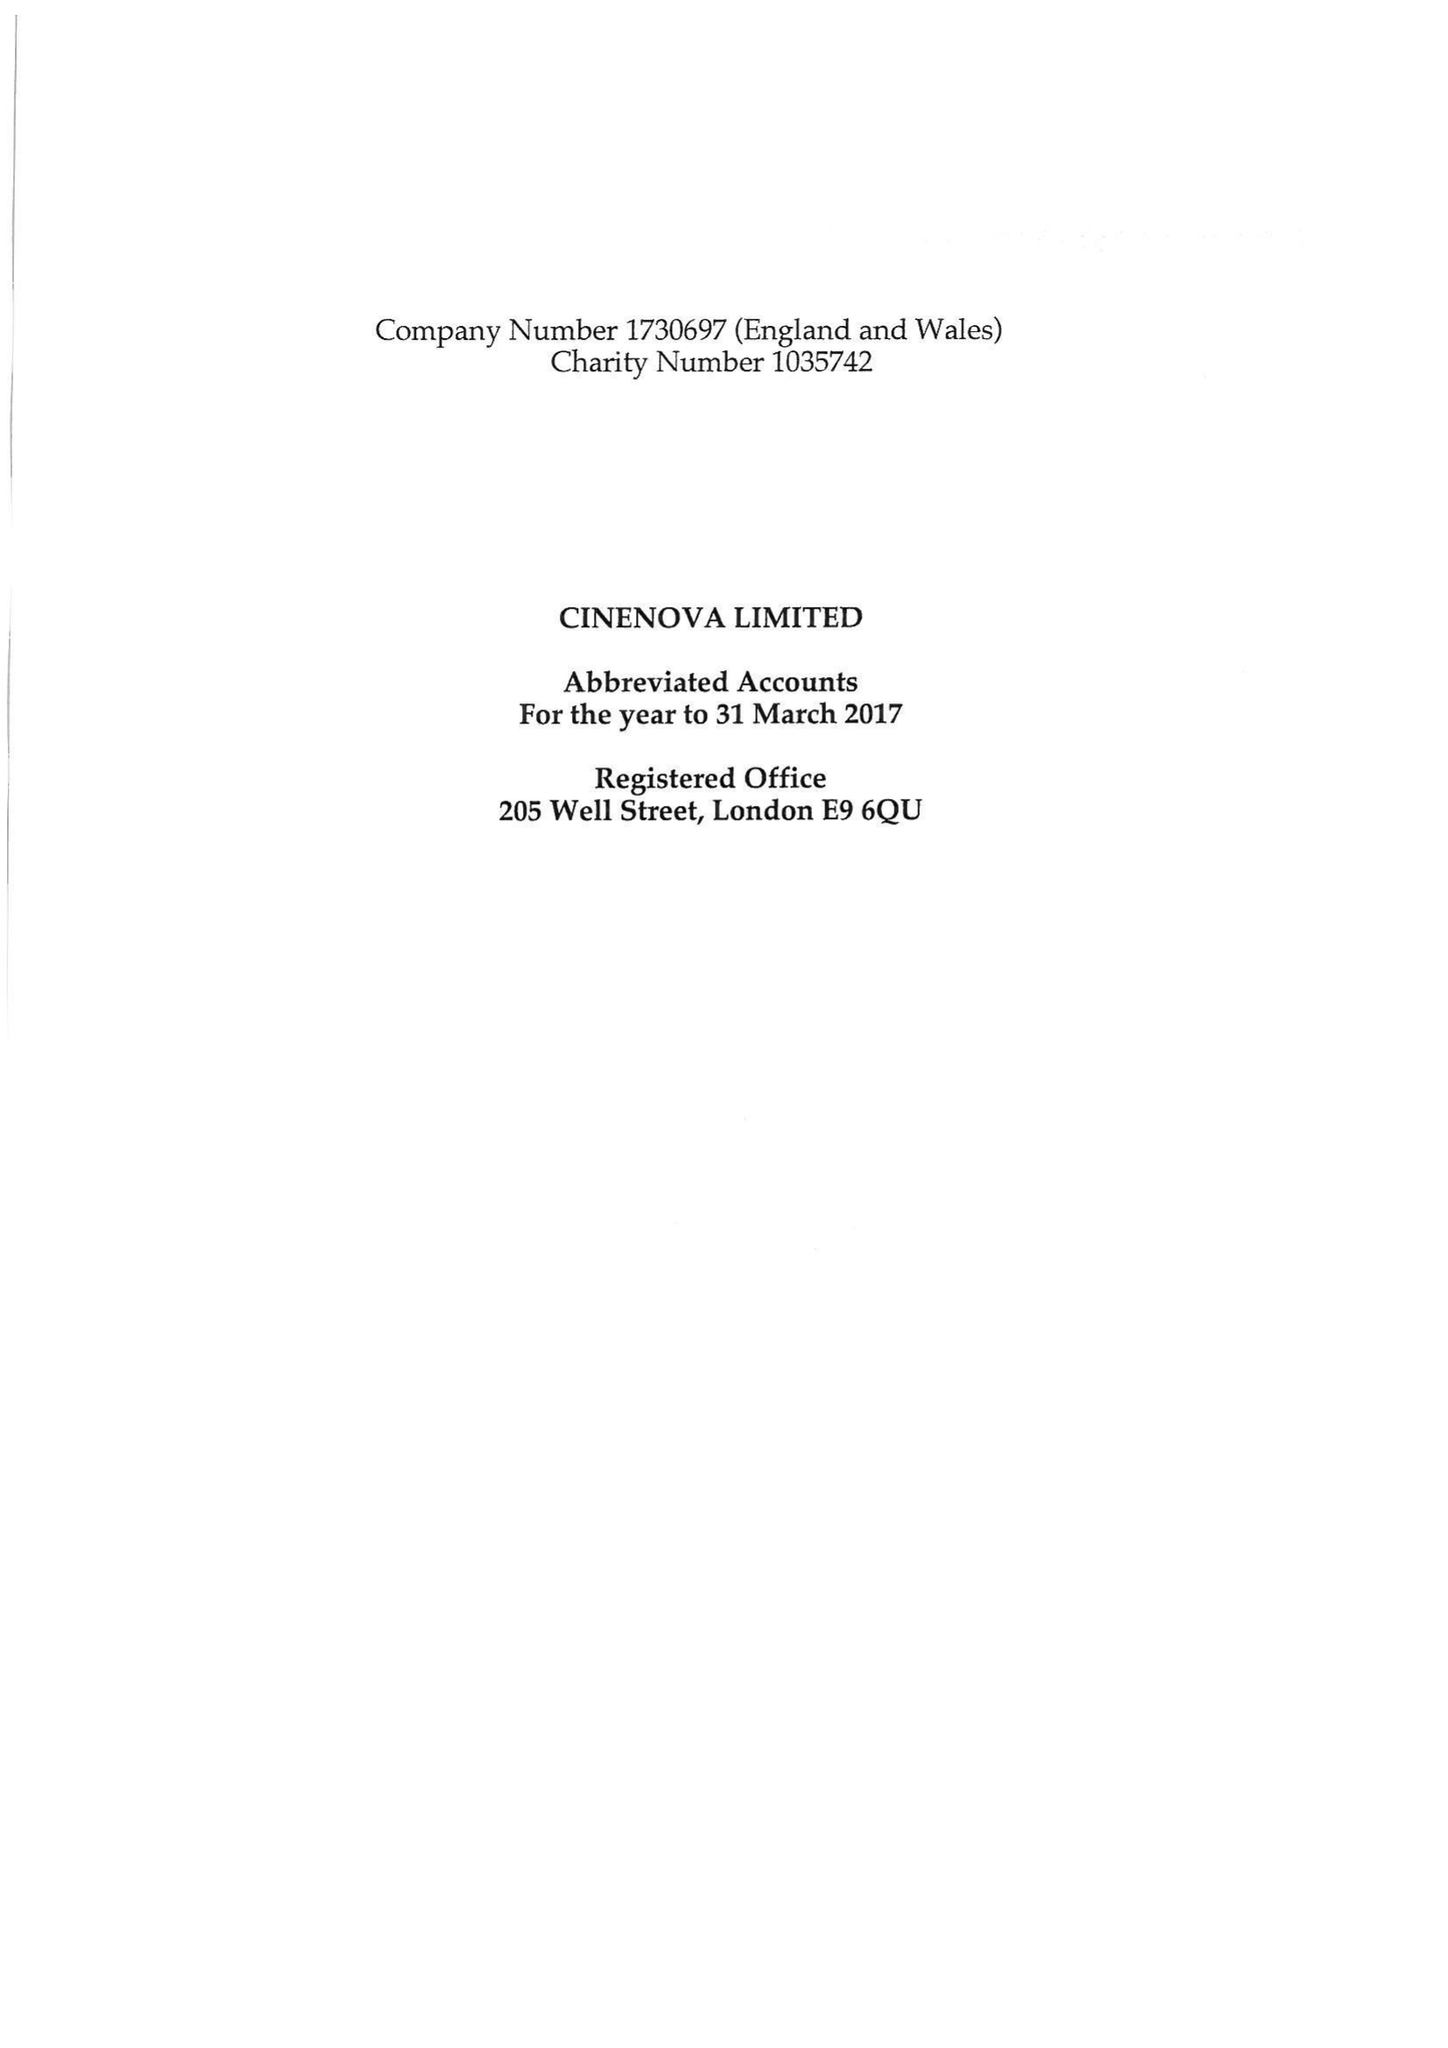What is the value for the address__street_line?
Answer the question using a single word or phrase. DARTMOUTH PARK HILL 